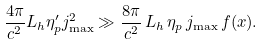Convert formula to latex. <formula><loc_0><loc_0><loc_500><loc_500>\frac { 4 \pi } { c ^ { 2 } } L _ { h } \eta _ { p } ^ { \prime } j _ { \max } ^ { 2 } \gg \frac { 8 \pi } { c ^ { 2 } } \, L _ { h } \, \eta _ { p } \, j _ { \max } \, f ( x ) .</formula> 